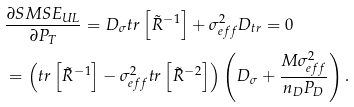<formula> <loc_0><loc_0><loc_500><loc_500>& \frac { \partial S M S E _ { U L } } { \partial P _ { T } } = D _ { \sigma } t r \left [ \tilde { R } ^ { - 1 } \right ] + \sigma _ { e f f } ^ { 2 } D _ { t r } = 0 \\ & = \left ( t r \left [ \tilde { R } ^ { - 1 } \right ] - \sigma _ { e f f } ^ { 2 } t r \left [ \tilde { R } ^ { - 2 } \right ] \right ) \left ( D _ { \sigma } + \frac { M \sigma _ { e f f } ^ { 2 } } { n _ { D } P _ { D } } \right ) .</formula> 